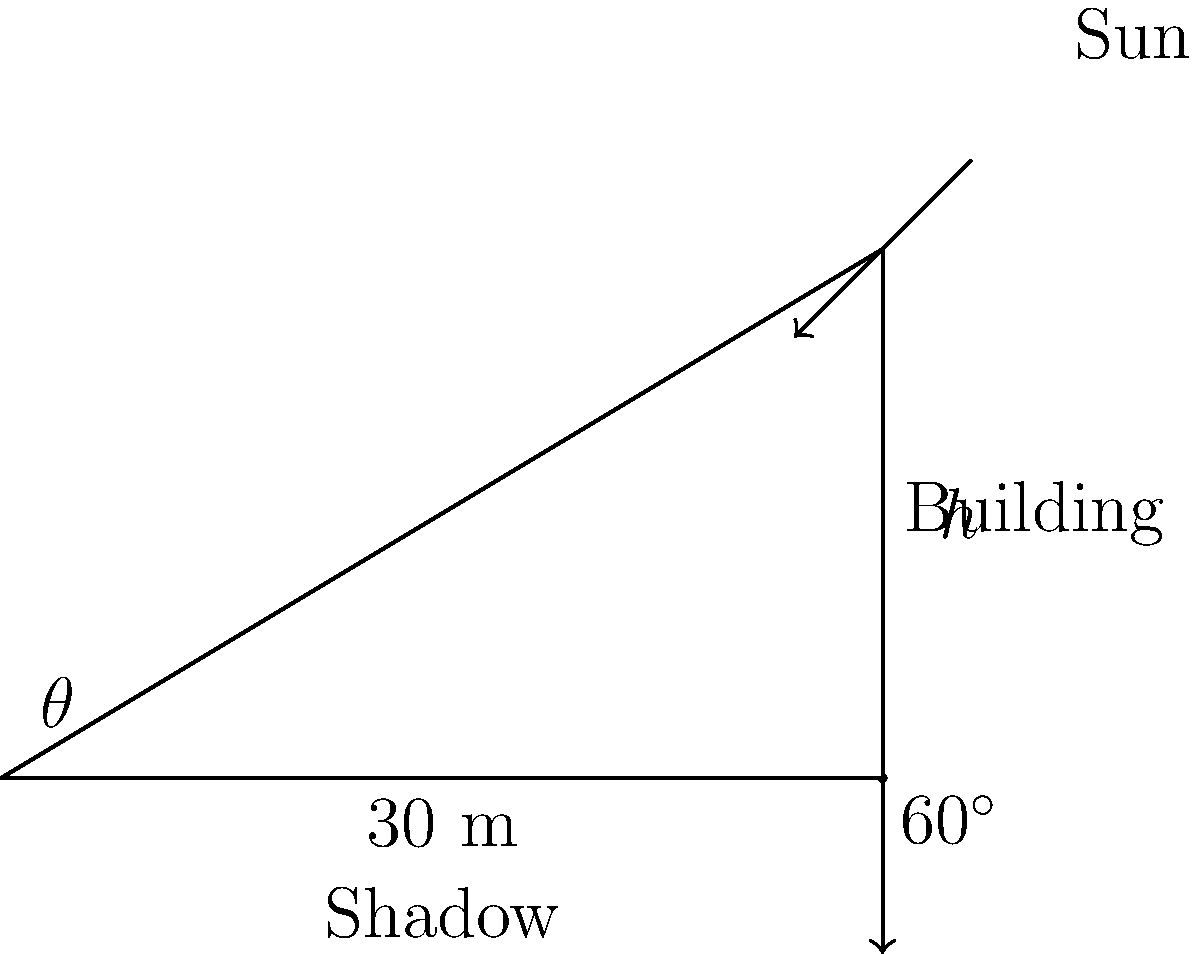In the latest "Hammer" adventure, our hero needs to determine the height of a mysterious building. The sun is casting a shadow at a $60^\circ$ angle, and the shadow's length is 30 meters. Using this information, calculate the height of the building to the nearest meter. Let's approach this step-by-step, using trigonometry:

1) In a right triangle, tangent of an angle is the ratio of the opposite side to the adjacent side.

2) In this case, we have:
   - The angle $\theta = 60^\circ$
   - The adjacent side (shadow length) = 30 m
   - The opposite side (building height) = $h$ (unknown)

3) We can set up the equation:
   $\tan 60^\circ = \frac{h}{30}$

4) We know that $\tan 60^\circ = \sqrt{3}$, so:
   $\sqrt{3} = \frac{h}{30}$

5) Solving for $h$:
   $h = 30 \sqrt{3}$

6) Calculate the value:
   $h = 30 \times 1.732... \approx 51.96$ meters

7) Rounding to the nearest meter:
   $h \approx 52$ meters
Answer: 52 meters 